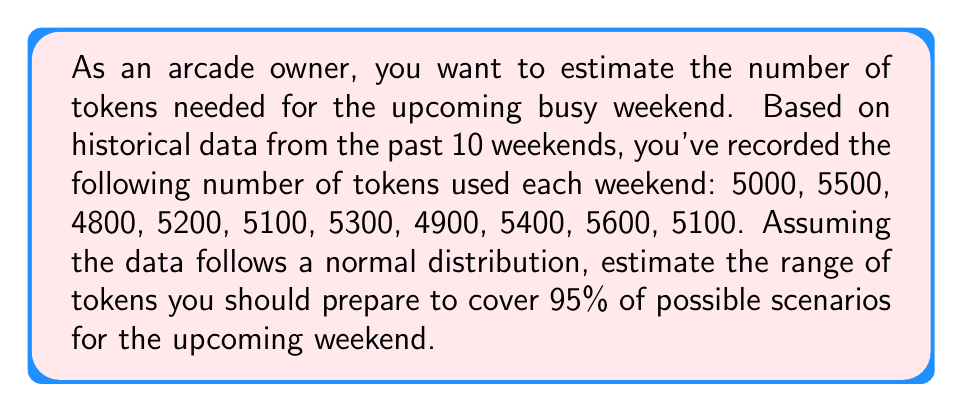What is the answer to this math problem? To solve this problem, we'll use the concept of confidence intervals for a normal distribution. Here's the step-by-step process:

1. Calculate the mean ($\bar{x}$) of the historical data:
   $$\bar{x} = \frac{5000 + 5500 + 4800 + 5200 + 5100 + 5300 + 4900 + 5400 + 5600 + 5100}{10} = 5190$$

2. Calculate the standard deviation ($s$) of the data:
   $$s = \sqrt{\frac{\sum_{i=1}^{n} (x_i - \bar{x})^2}{n-1}}$$
   $$s \approx 261.20$$

3. For a 95% confidence interval, we use a z-score of 1.96 (from the standard normal distribution table).

4. Calculate the margin of error:
   $$\text{Margin of Error} = z \cdot \frac{s}{\sqrt{n}} = 1.96 \cdot \frac{261.20}{\sqrt{10}} \approx 162.06$$

5. Calculate the confidence interval:
   $$\text{Lower bound} = \bar{x} - \text{Margin of Error} = 5190 - 162.06 \approx 5027.94$$
   $$\text{Upper bound} = \bar{x} + \text{Margin of Error} = 5190 + 162.06 \approx 5352.06$$

6. Round the results to the nearest whole number of tokens.
Answer: Prepare between 5028 and 5352 tokens to cover 95% of possible scenarios for the upcoming busy weekend. 